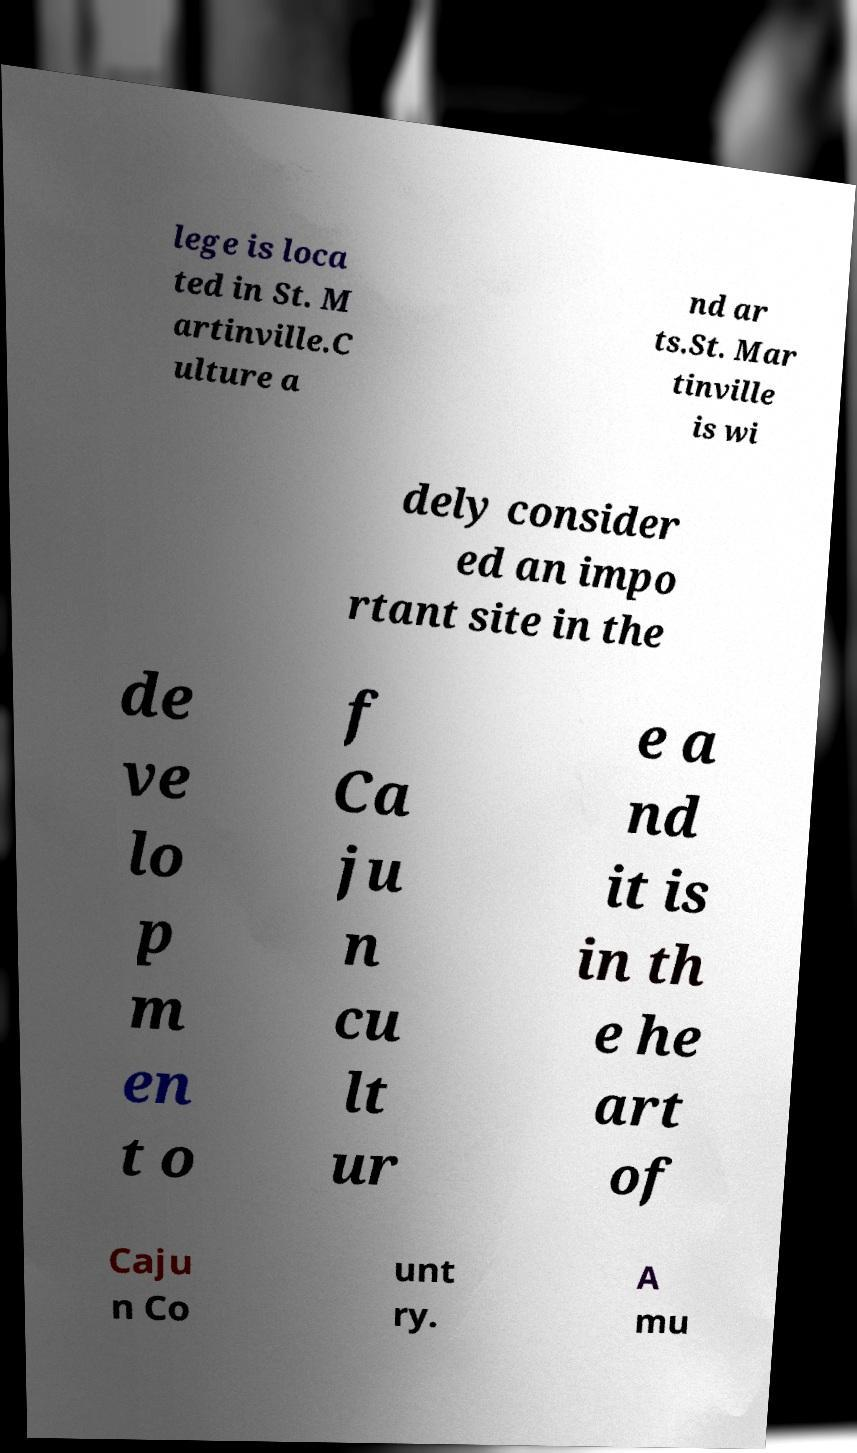I need the written content from this picture converted into text. Can you do that? lege is loca ted in St. M artinville.C ulture a nd ar ts.St. Mar tinville is wi dely consider ed an impo rtant site in the de ve lo p m en t o f Ca ju n cu lt ur e a nd it is in th e he art of Caju n Co unt ry. A mu 